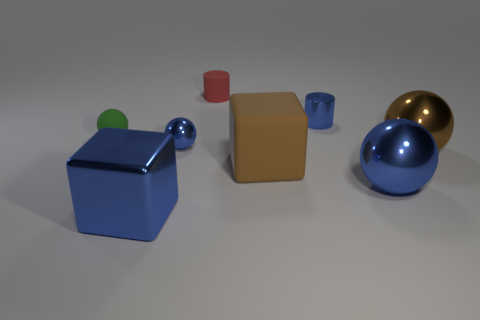There is a brown thing that is behind the large brown rubber block; is it the same size as the matte object that is in front of the green sphere?
Your response must be concise. Yes. How many things are red matte cylinders that are behind the big blue metal block or blue metal objects that are behind the green object?
Your answer should be very brief. 2. Do the tiny green ball and the big cube on the right side of the small red thing have the same material?
Your answer should be very brief. Yes. The rubber thing that is both right of the small green thing and behind the brown metal sphere has what shape?
Ensure brevity in your answer.  Cylinder. How many other things are there of the same color as the small rubber cylinder?
Provide a short and direct response. 0. There is a red thing; what shape is it?
Offer a terse response. Cylinder. The metallic sphere behind the large object that is on the right side of the big blue shiny ball is what color?
Make the answer very short. Blue. Do the shiny cylinder and the metal sphere that is on the left side of the tiny blue cylinder have the same color?
Ensure brevity in your answer.  Yes. There is a object that is on the right side of the brown rubber block and behind the tiny green rubber thing; what material is it?
Offer a terse response. Metal. Are there any balls of the same size as the brown matte object?
Provide a short and direct response. Yes. 